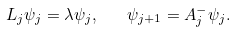<formula> <loc_0><loc_0><loc_500><loc_500>L _ { j } \psi _ { j } = \lambda \psi _ { j } , \quad \psi _ { j + 1 } = A ^ { - } _ { j } \psi _ { j } .</formula> 